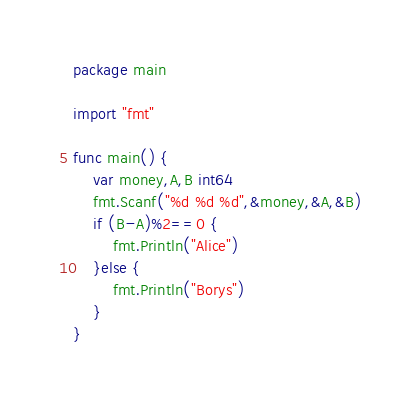Convert code to text. <code><loc_0><loc_0><loc_500><loc_500><_Go_>package main

import "fmt"

func main() {
	var money,A,B int64
	fmt.Scanf("%d %d %d",&money,&A,&B)
	if (B-A)%2==0 {
		fmt.Println("Alice")
	}else {
		fmt.Println("Borys")
	}
}</code> 